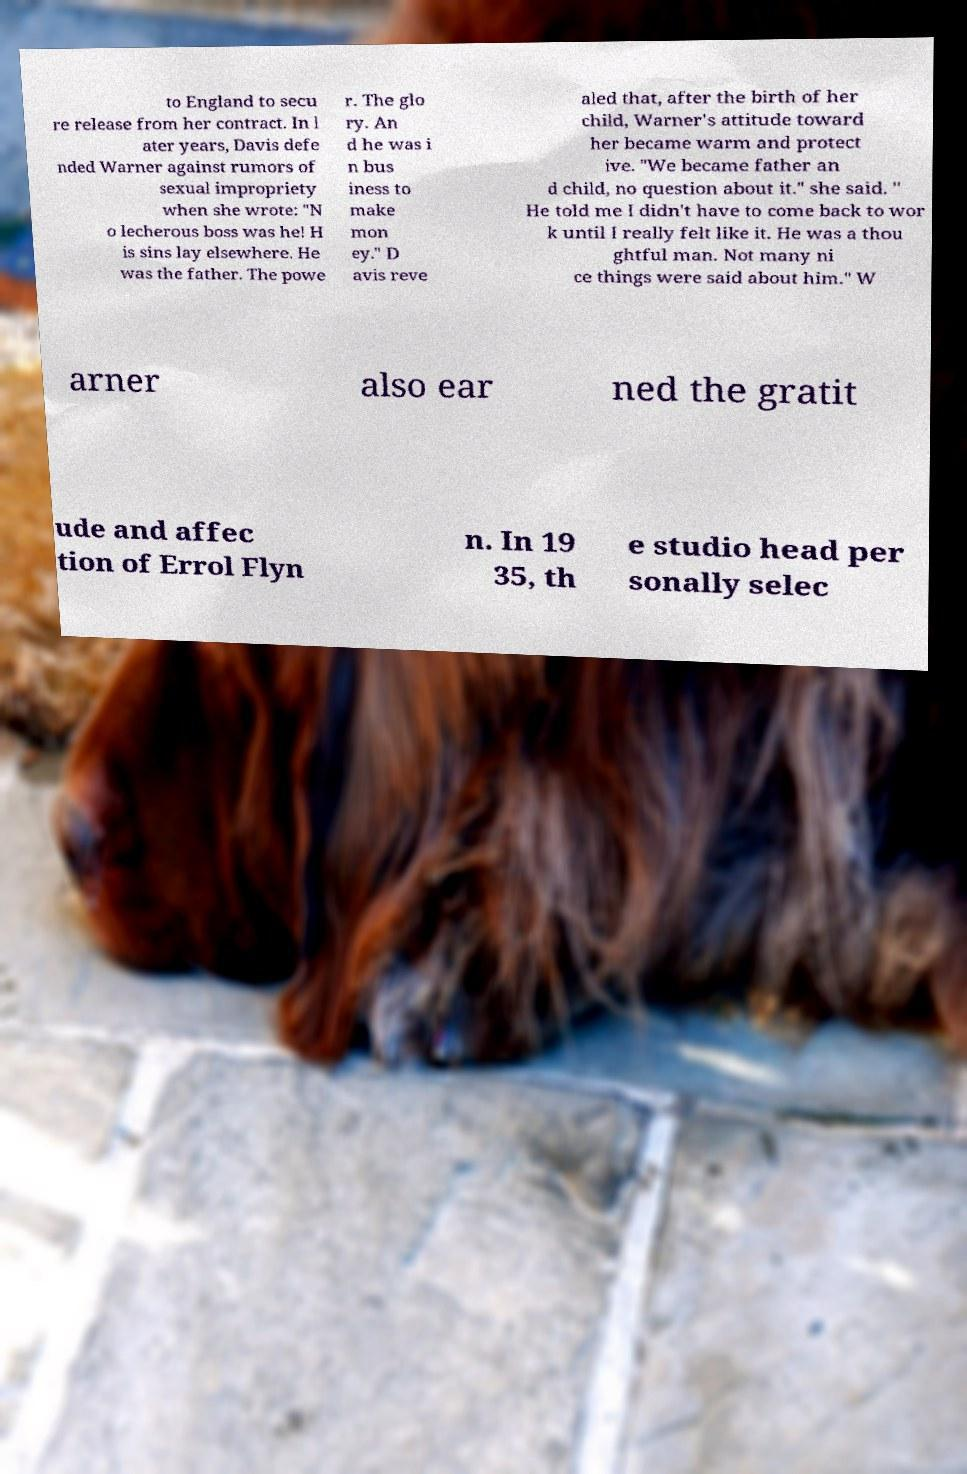Could you extract and type out the text from this image? to England to secu re release from her contract. In l ater years, Davis defe nded Warner against rumors of sexual impropriety when she wrote: "N o lecherous boss was he! H is sins lay elsewhere. He was the father. The powe r. The glo ry. An d he was i n bus iness to make mon ey." D avis reve aled that, after the birth of her child, Warner's attitude toward her became warm and protect ive. "We became father an d child, no question about it." she said. " He told me I didn't have to come back to wor k until I really felt like it. He was a thou ghtful man. Not many ni ce things were said about him." W arner also ear ned the gratit ude and affec tion of Errol Flyn n. In 19 35, th e studio head per sonally selec 